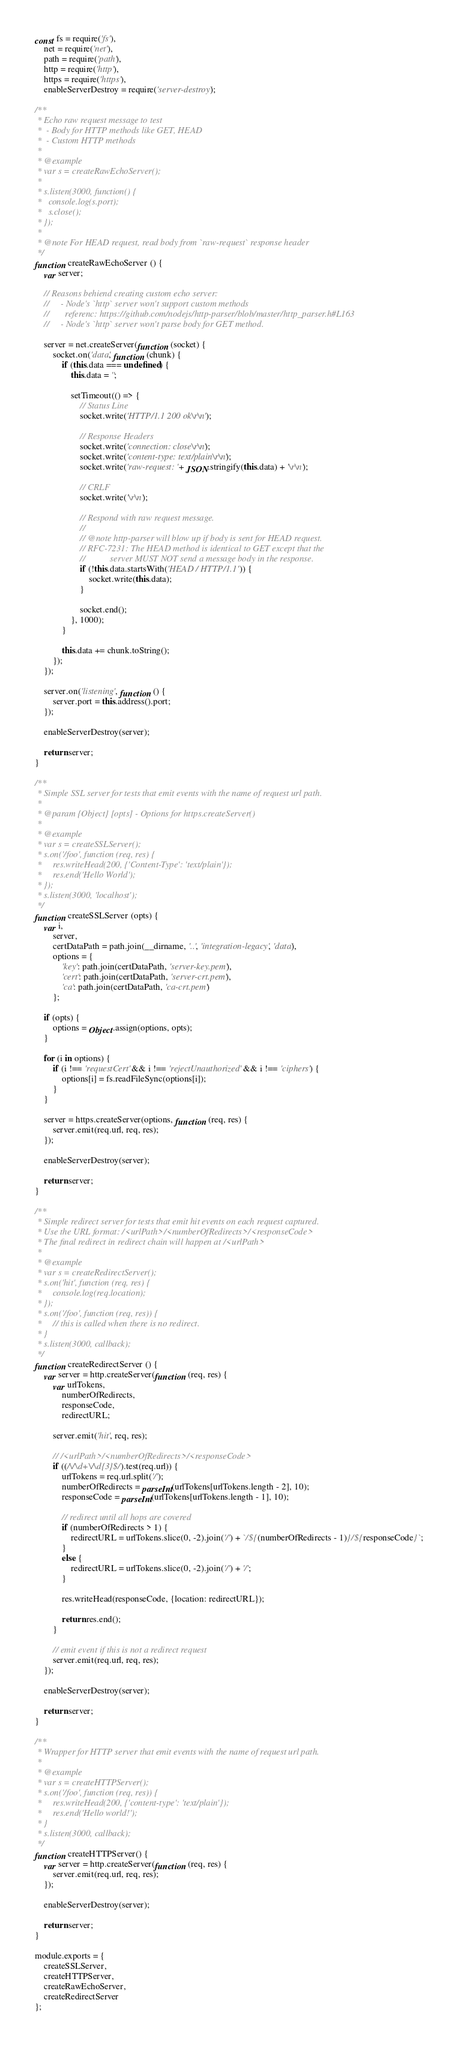Convert code to text. <code><loc_0><loc_0><loc_500><loc_500><_JavaScript_>const fs = require('fs'),
    net = require('net'),
    path = require('path'),
    http = require('http'),
    https = require('https'),
    enableServerDestroy = require('server-destroy');

/**
 * Echo raw request message to test
 *  - Body for HTTP methods like GET, HEAD
 *  - Custom HTTP methods
 *
 * @example
 * var s = createRawEchoServer();
 *
 * s.listen(3000, function() {
 *   console.log(s.port);
 *   s.close();
 * });
 *
 * @note For HEAD request, read body from `raw-request` response header
 */
function createRawEchoServer () {
    var server;

    // Reasons behiend creating custom echo server:
    //     - Node's `http` server won't support custom methods
    //       referenc: https://github.com/nodejs/http-parser/blob/master/http_parser.h#L163
    //     - Node's `http` server won't parse body for GET method.

    server = net.createServer(function (socket) {
        socket.on('data', function (chunk) {
            if (this.data === undefined) {
                this.data = '';

                setTimeout(() => {
                    // Status Line
                    socket.write('HTTP/1.1 200 ok\r\n');

                    // Response Headers
                    socket.write('connection: close\r\n');
                    socket.write('content-type: text/plain\r\n');
                    socket.write('raw-request: ' + JSON.stringify(this.data) + '\r\n');

                    // CRLF
                    socket.write('\r\n');

                    // Respond with raw request message.
                    //
                    // @note http-parser will blow up if body is sent for HEAD request.
                    // RFC-7231: The HEAD method is identical to GET except that the
                    //           server MUST NOT send a message body in the response.
                    if (!this.data.startsWith('HEAD / HTTP/1.1')) {
                        socket.write(this.data);
                    }

                    socket.end();
                }, 1000);
            }

            this.data += chunk.toString();
        });
    });

    server.on('listening', function () {
        server.port = this.address().port;
    });

    enableServerDestroy(server);

    return server;
}

/**
 * Simple SSL server for tests that emit events with the name of request url path.
 *
 * @param {Object} [opts] - Options for https.createServer()
 *
 * @example
 * var s = createSSLServer();
 * s.on('/foo', function (req, res) {
 *     res.writeHead(200, {'Content-Type': 'text/plain'});
 *     res.end('Hello World');
 * });
 * s.listen(3000, 'localhost');
 */
function createSSLServer (opts) {
    var i,
        server,
        certDataPath = path.join(__dirname, '..', 'integration-legacy', 'data'),
        options = {
            'key': path.join(certDataPath, 'server-key.pem'),
            'cert': path.join(certDataPath, 'server-crt.pem'),
            'ca': path.join(certDataPath, 'ca-crt.pem')
        };

    if (opts) {
        options = Object.assign(options, opts);
    }

    for (i in options) {
        if (i !== 'requestCert' && i !== 'rejectUnauthorized' && i !== 'ciphers') {
            options[i] = fs.readFileSync(options[i]);
        }
    }

    server = https.createServer(options, function (req, res) {
        server.emit(req.url, req, res);
    });

    enableServerDestroy(server);

    return server;
}

/**
 * Simple redirect server for tests that emit hit events on each request captured.
 * Use the URL format: /<urlPath>/<numberOfRedirects>/<responseCode>
 * The final redirect in redirect chain will happen at /<urlPath>
 *
 * @example
 * var s = createRedirectServer();
 * s.on('hit', function (req, res) {
 *     console.log(req.location);
 * });
 * s.on('/foo', function (req, res)) {
 *     // this is called when there is no redirect.
 * }
 * s.listen(3000, callback);
 */
function createRedirectServer () {
    var server = http.createServer(function (req, res) {
        var urlTokens,
            numberOfRedirects,
            responseCode,
            redirectURL;

        server.emit('hit', req, res);

        // /<urlPath>/<numberOfRedirects>/<responseCode>
        if ((/\/\d+\/\d{3}$/).test(req.url)) {
            urlTokens = req.url.split('/');
            numberOfRedirects = parseInt(urlTokens[urlTokens.length - 2], 10);
            responseCode = parseInt(urlTokens[urlTokens.length - 1], 10);

            // redirect until all hops are covered
            if (numberOfRedirects > 1) {
                redirectURL = urlTokens.slice(0, -2).join('/') + `/${(numberOfRedirects - 1)}/${responseCode}`;
            }
            else {
                redirectURL = urlTokens.slice(0, -2).join('/') + '/';
            }

            res.writeHead(responseCode, {location: redirectURL});

            return res.end();
        }

        // emit event if this is not a redirect request
        server.emit(req.url, req, res);
    });

    enableServerDestroy(server);

    return server;
}

/**
 * Wrapper for HTTP server that emit events with the name of request url path.
 *
 * @example
 * var s = createHTTPServer();
 * s.on('/foo', function (req, res)) {
 *     res.writeHead(200, {'content-type': 'text/plain'});
 *     res.end('Hello world!');
 * }
 * s.listen(3000, callback);
 */
function createHTTPServer() {
    var server = http.createServer(function (req, res) {
        server.emit(req.url, req, res);
    });

    enableServerDestroy(server);

    return server;
}

module.exports = {
    createSSLServer,
    createHTTPServer,
    createRawEchoServer,
    createRedirectServer
};
</code> 